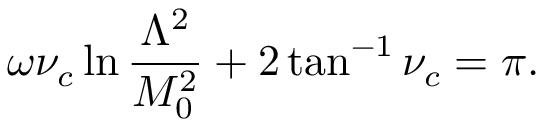<formula> <loc_0><loc_0><loc_500><loc_500>\omega \nu _ { c } \ln \frac { \Lambda ^ { 2 } } { M _ { 0 } ^ { 2 } } + 2 \tan ^ { - 1 } \nu _ { c } = \pi .</formula> 